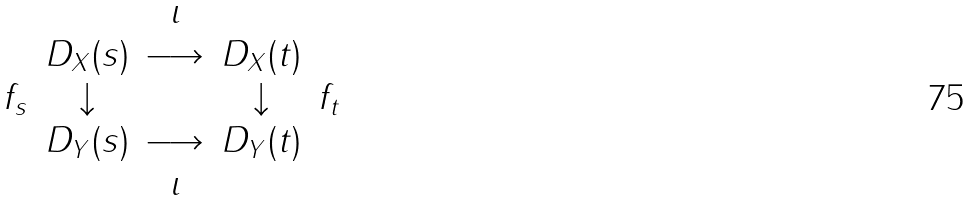Convert formula to latex. <formula><loc_0><loc_0><loc_500><loc_500>\begin{matrix} & & \iota & & \\ & D _ { X } ( s ) & \longrightarrow & D _ { X } ( t ) & \\ f _ { s } & \downarrow & & \downarrow & f _ { t } \\ & D _ { Y } ( s ) & \longrightarrow & D _ { Y } ( t ) & \\ & & \iota & & \end{matrix}</formula> 